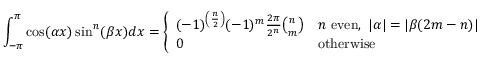Convert formula to latex. <formula><loc_0><loc_0><loc_500><loc_500>\int _ { - \pi } ^ { \pi } \cos ( \alpha x ) \sin ^ { n } ( \beta x ) d x = { \left \{ \begin{array} { l l } { ( - 1 ) ^ { \left ( { \frac { n } { 2 } } \right ) } ( - 1 ) ^ { m } { \frac { 2 \pi } { 2 ^ { n } } } { \binom { n } { m } } } & { n { e v e n } , \ | \alpha | = | \beta ( 2 m - n ) | } \\ { 0 } & { o t h e r w i s e } \end{array} }</formula> 